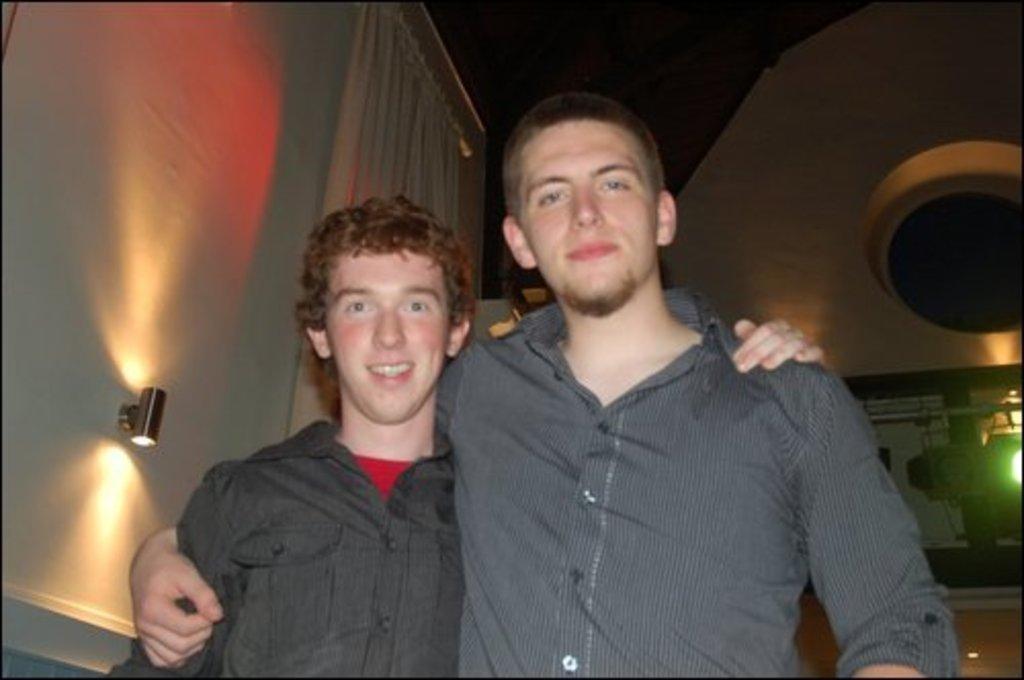Please provide a concise description of this image. In this picture we can see two men smiling. In the background we can see the lights, walls, curtain, some objects and it is dark. 